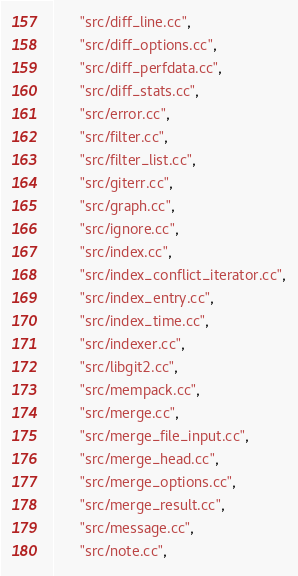<code> <loc_0><loc_0><loc_500><loc_500><_Python_>      "src/diff_line.cc",
      "src/diff_options.cc",
      "src/diff_perfdata.cc",
      "src/diff_stats.cc",
      "src/error.cc",
      "src/filter.cc",
      "src/filter_list.cc",
      "src/giterr.cc",
      "src/graph.cc",
      "src/ignore.cc",
      "src/index.cc",
      "src/index_conflict_iterator.cc",
      "src/index_entry.cc",
      "src/index_time.cc",
      "src/indexer.cc",
      "src/libgit2.cc",
      "src/mempack.cc",
      "src/merge.cc",
      "src/merge_file_input.cc",
      "src/merge_head.cc",
      "src/merge_options.cc",
      "src/merge_result.cc",
      "src/message.cc",
      "src/note.cc",</code> 